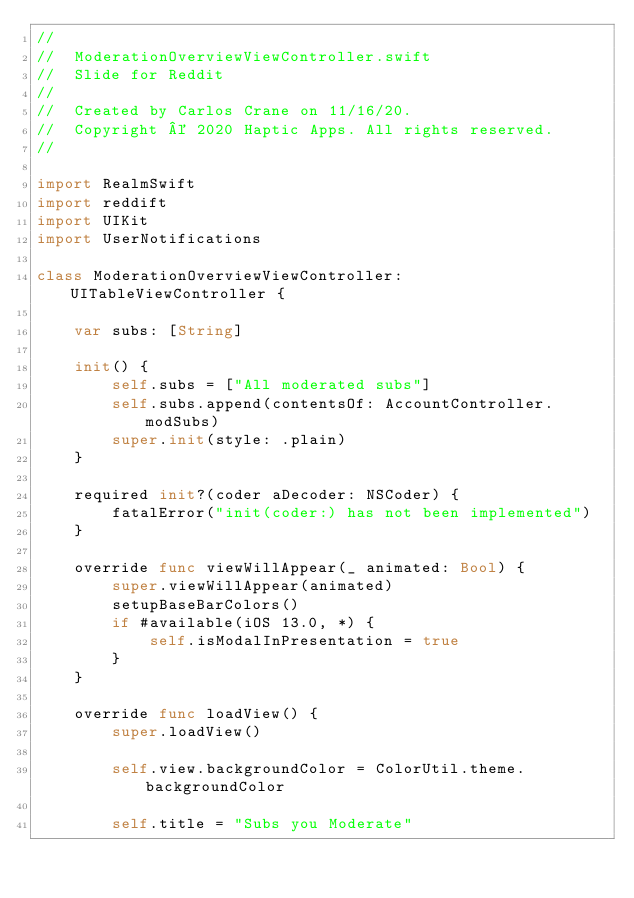<code> <loc_0><loc_0><loc_500><loc_500><_Swift_>//
//  ModerationOverviewViewController.swift
//  Slide for Reddit
//
//  Created by Carlos Crane on 11/16/20.
//  Copyright © 2020 Haptic Apps. All rights reserved.
//

import RealmSwift
import reddift
import UIKit
import UserNotifications

class ModerationOverviewViewController: UITableViewController {
    
    var subs: [String]
    
    init() {
        self.subs = ["All moderated subs"]
        self.subs.append(contentsOf: AccountController.modSubs)
        super.init(style: .plain)
    }
    
    required init?(coder aDecoder: NSCoder) {
        fatalError("init(coder:) has not been implemented")
    }
    
    override func viewWillAppear(_ animated: Bool) {
        super.viewWillAppear(animated)
        setupBaseBarColors()
        if #available(iOS 13.0, *) {
            self.isModalInPresentation = true
        }
    }
    
    override func loadView() {
        super.loadView()
        
        self.view.backgroundColor = ColorUtil.theme.backgroundColor

        self.title = "Subs you Moderate"</code> 